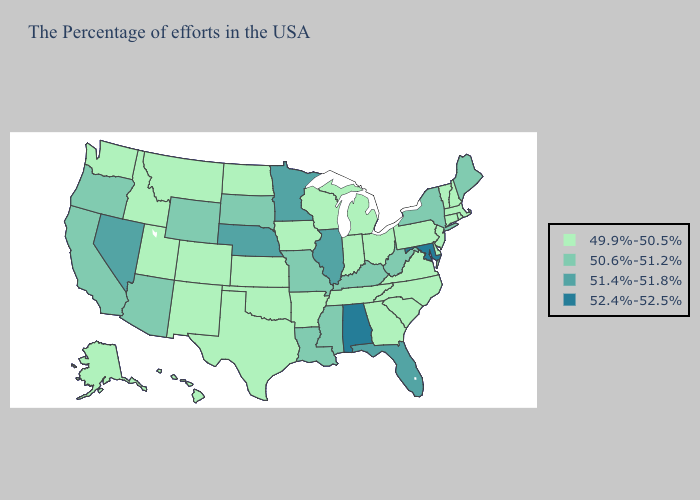Is the legend a continuous bar?
Answer briefly. No. Name the states that have a value in the range 52.4%-52.5%?
Quick response, please. Maryland, Alabama. Among the states that border Texas , which have the highest value?
Be succinct. Louisiana. Among the states that border Montana , does Idaho have the highest value?
Give a very brief answer. No. Does Virginia have the same value as Hawaii?
Quick response, please. Yes. Does the map have missing data?
Write a very short answer. No. What is the highest value in the USA?
Write a very short answer. 52.4%-52.5%. What is the value of Mississippi?
Answer briefly. 50.6%-51.2%. Does Texas have the highest value in the USA?
Answer briefly. No. What is the value of Maine?
Give a very brief answer. 50.6%-51.2%. Among the states that border New Mexico , which have the highest value?
Give a very brief answer. Arizona. Name the states that have a value in the range 51.4%-51.8%?
Answer briefly. Florida, Illinois, Minnesota, Nebraska, Nevada. Name the states that have a value in the range 49.9%-50.5%?
Give a very brief answer. Massachusetts, Rhode Island, New Hampshire, Vermont, Connecticut, New Jersey, Delaware, Pennsylvania, Virginia, North Carolina, South Carolina, Ohio, Georgia, Michigan, Indiana, Tennessee, Wisconsin, Arkansas, Iowa, Kansas, Oklahoma, Texas, North Dakota, Colorado, New Mexico, Utah, Montana, Idaho, Washington, Alaska, Hawaii. Name the states that have a value in the range 51.4%-51.8%?
Write a very short answer. Florida, Illinois, Minnesota, Nebraska, Nevada. 